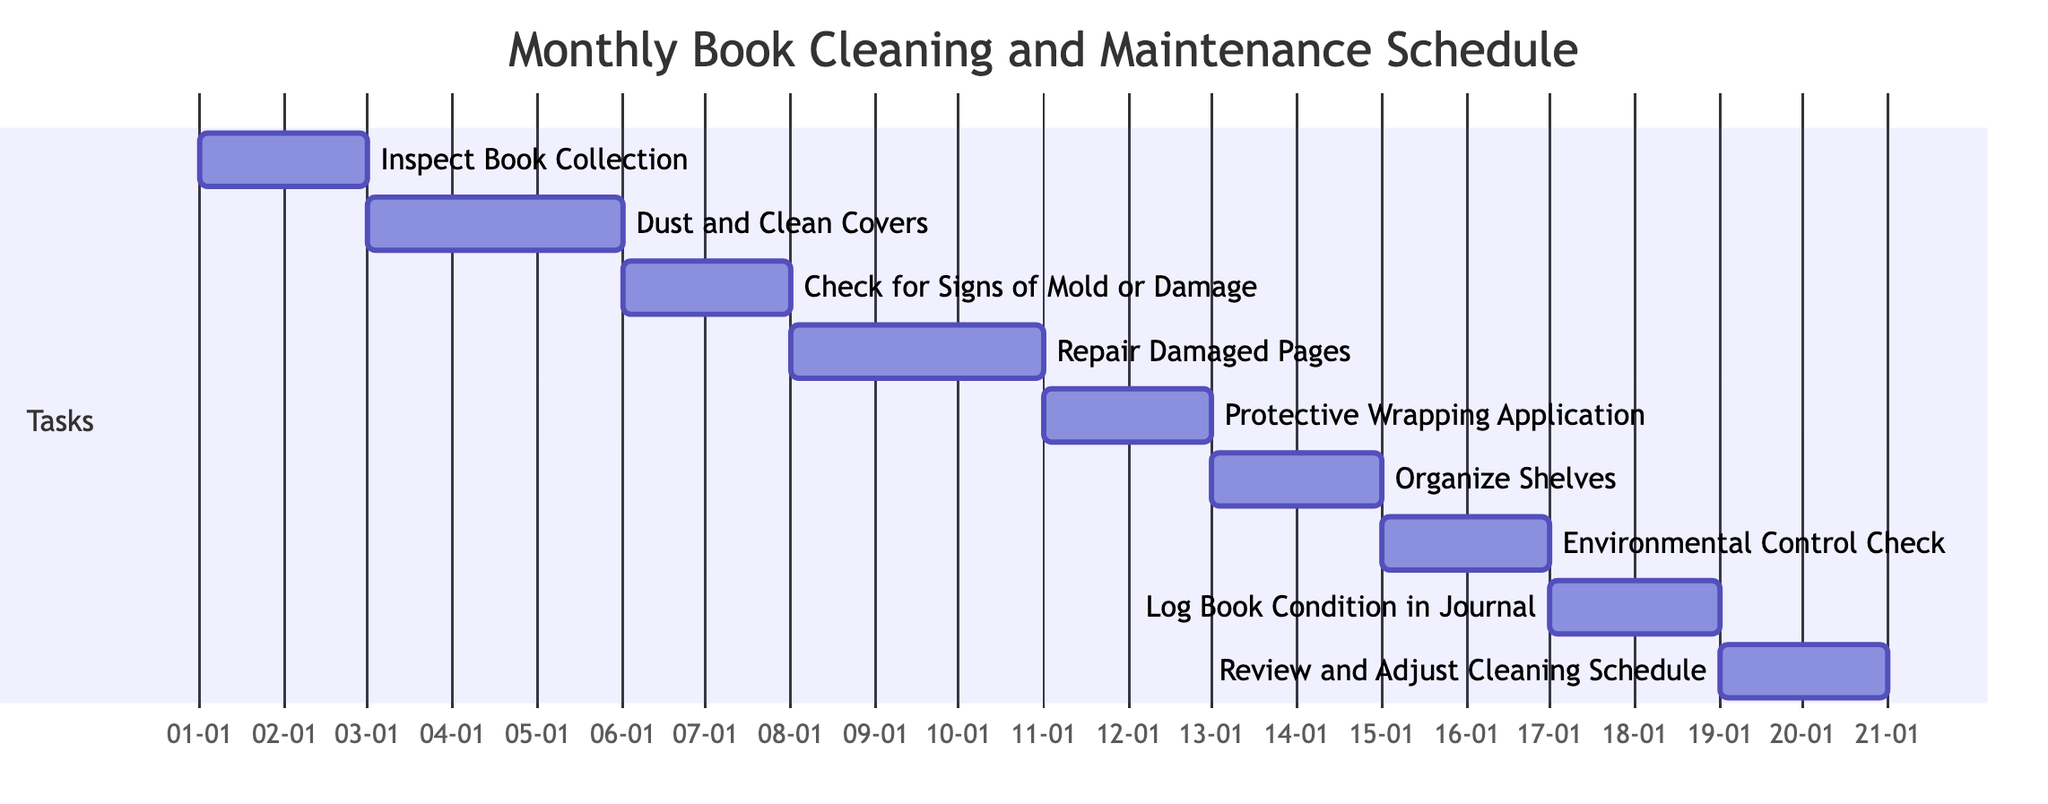What is the total number of tasks in the schedule? The diagram lists tasks numbered from 1 to 9, showing a total of 9 distinct tasks aimed at cleaning and maintaining books.
Answer: 9 What is the duration of "Repair Damaged Pages"? The task "Repair Damaged Pages" starts on 01-08-2023 and ends on 01-10-2023, giving it a duration of 3 days (2 days for the start and end, plus 1 day in between).
Answer: 3 days Which task follows "Check for Signs of Mold or Damage"? Referring to the dependencies, "Repair Damaged Pages" directly follows "Check for Signs of Mold or Damage", as it is listed as dependent on it.
Answer: Repair Damaged Pages When does the "Dust and Clean Covers" task begin? The diagram indicates the start date of the "Dust and Clean Covers" task as 01-03-2023, right after the completion of the task it depends on.
Answer: 01-03-2023 What task requires "Organize Shelves" to be completed first? "Environmental Control Check (humidity, temperature)" is dependent on the completion of the "Organize Shelves" task, indicating it cannot start until "Organize Shelves" is finished.
Answer: Environmental Control Check How many tasks start on the same day as "Protective Wrapping Application"? The task "Protective Wrapping Application" starts on 01-11-2023, and according to the diagram, it is the only task starting on this date, so there are no other tasks beginning simultaneously.
Answer: 0 What is the end date of the last task in the schedule? The last task in the schedule is "Review and Adjust Cleaning Schedule," which ends on 01-20-2023, marking the conclusion of the maintenance schedule timeline.
Answer: 01-20-2023 Which task needs to be completed before "Log Book Condition in Journal"? The task "Log Book Condition in Journal" comes after "Environmental Control Check", indicating that it must be completed prior to moving on to logging the book's condition.
Answer: Environmental Control Check How many days are allocated for tasks that involve cleaning? The tasks involving cleaning are "Inspect Book Collection" (2 days), "Dust and Clean Covers" (3 days), and "Check for Signs of Mold or Damage" (2 days). Adding these gives a total of 7 days dedicated to cleaning activities.
Answer: 7 days 